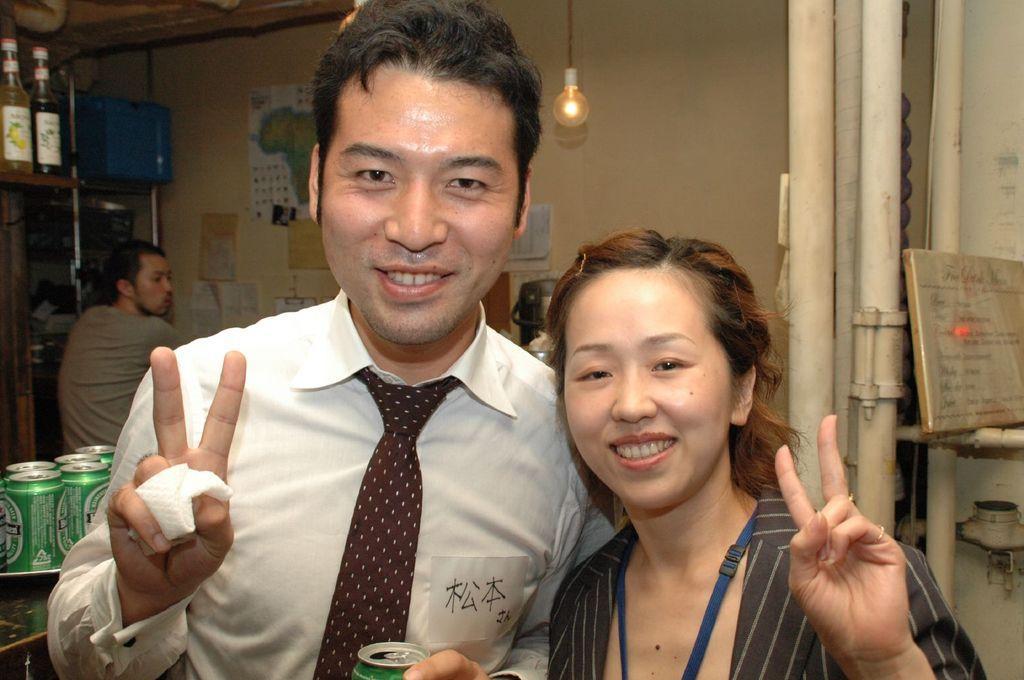Please provide a concise description of this image. In this image I can see two people with different color dresses. I can see one person is holding the tin. To the left there are few more things which are in green color. These are on the black color surface. In the back I can see one more person and there are many papers to the wall. To the side I can see the rack. And there are bottles and blue color box inside the rack. I can see the bulb and the board to the right. 